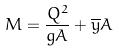Convert formula to latex. <formula><loc_0><loc_0><loc_500><loc_500>M = \frac { Q ^ { 2 } } { g A } + \overline { y } A</formula> 